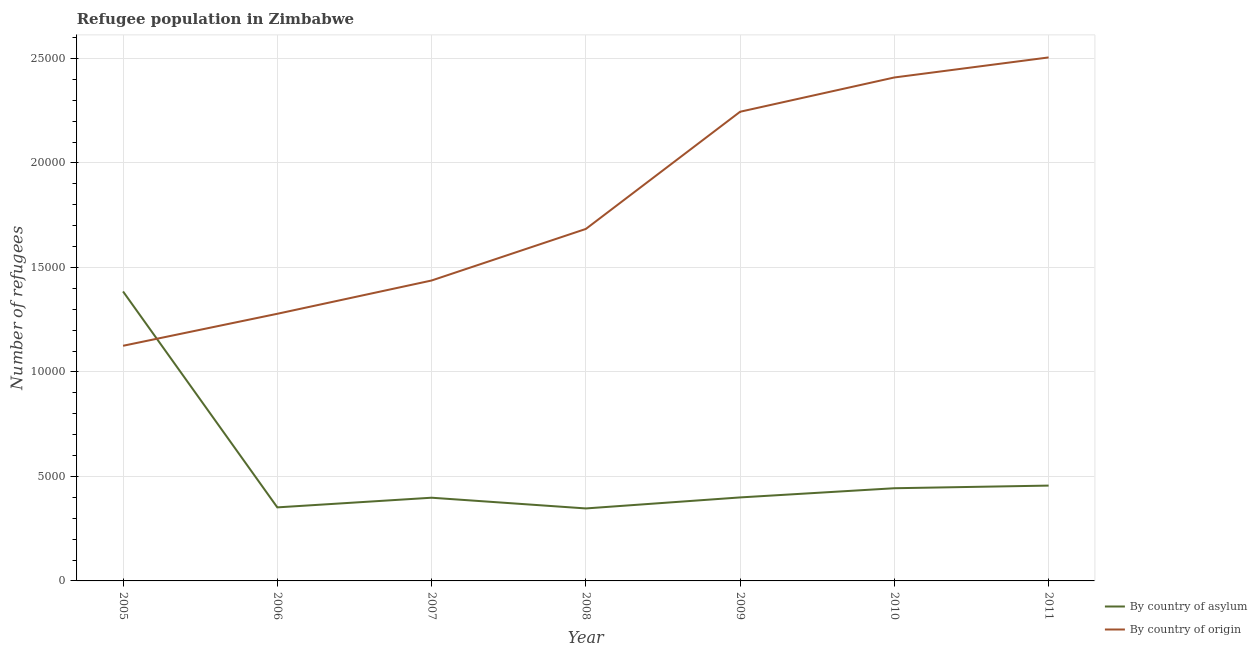Does the line corresponding to number of refugees by country of asylum intersect with the line corresponding to number of refugees by country of origin?
Provide a succinct answer. Yes. Is the number of lines equal to the number of legend labels?
Offer a very short reply. Yes. What is the number of refugees by country of origin in 2011?
Provide a succinct answer. 2.50e+04. Across all years, what is the maximum number of refugees by country of origin?
Offer a terse response. 2.50e+04. Across all years, what is the minimum number of refugees by country of asylum?
Ensure brevity in your answer.  3468. In which year was the number of refugees by country of origin maximum?
Provide a succinct answer. 2011. In which year was the number of refugees by country of origin minimum?
Your response must be concise. 2005. What is the total number of refugees by country of asylum in the graph?
Make the answer very short. 3.78e+04. What is the difference between the number of refugees by country of origin in 2007 and that in 2011?
Keep it short and to the point. -1.07e+04. What is the difference between the number of refugees by country of origin in 2009 and the number of refugees by country of asylum in 2006?
Keep it short and to the point. 1.89e+04. What is the average number of refugees by country of origin per year?
Make the answer very short. 1.81e+04. In the year 2006, what is the difference between the number of refugees by country of origin and number of refugees by country of asylum?
Make the answer very short. 9263. In how many years, is the number of refugees by country of origin greater than 10000?
Offer a very short reply. 7. What is the ratio of the number of refugees by country of origin in 2006 to that in 2010?
Make the answer very short. 0.53. What is the difference between the highest and the second highest number of refugees by country of asylum?
Your response must be concise. 9289. What is the difference between the highest and the lowest number of refugees by country of asylum?
Your answer should be very brief. 1.04e+04. Does the number of refugees by country of origin monotonically increase over the years?
Provide a succinct answer. Yes. Is the number of refugees by country of asylum strictly less than the number of refugees by country of origin over the years?
Your response must be concise. No. How many lines are there?
Ensure brevity in your answer.  2. What is the difference between two consecutive major ticks on the Y-axis?
Your response must be concise. 5000. Are the values on the major ticks of Y-axis written in scientific E-notation?
Provide a succinct answer. No. What is the title of the graph?
Provide a short and direct response. Refugee population in Zimbabwe. What is the label or title of the Y-axis?
Offer a terse response. Number of refugees. What is the Number of refugees in By country of asylum in 2005?
Provide a short and direct response. 1.38e+04. What is the Number of refugees in By country of origin in 2005?
Offer a terse response. 1.13e+04. What is the Number of refugees of By country of asylum in 2006?
Provide a succinct answer. 3519. What is the Number of refugees in By country of origin in 2006?
Your answer should be very brief. 1.28e+04. What is the Number of refugees in By country of asylum in 2007?
Your answer should be compact. 3981. What is the Number of refugees in By country of origin in 2007?
Your answer should be compact. 1.44e+04. What is the Number of refugees of By country of asylum in 2008?
Provide a succinct answer. 3468. What is the Number of refugees of By country of origin in 2008?
Your answer should be very brief. 1.68e+04. What is the Number of refugees of By country of asylum in 2009?
Offer a terse response. 3995. What is the Number of refugees in By country of origin in 2009?
Make the answer very short. 2.24e+04. What is the Number of refugees of By country of asylum in 2010?
Your answer should be very brief. 4435. What is the Number of refugees in By country of origin in 2010?
Offer a terse response. 2.41e+04. What is the Number of refugees in By country of asylum in 2011?
Provide a short and direct response. 4561. What is the Number of refugees in By country of origin in 2011?
Keep it short and to the point. 2.50e+04. Across all years, what is the maximum Number of refugees in By country of asylum?
Offer a very short reply. 1.38e+04. Across all years, what is the maximum Number of refugees of By country of origin?
Provide a short and direct response. 2.50e+04. Across all years, what is the minimum Number of refugees of By country of asylum?
Offer a terse response. 3468. Across all years, what is the minimum Number of refugees of By country of origin?
Keep it short and to the point. 1.13e+04. What is the total Number of refugees of By country of asylum in the graph?
Ensure brevity in your answer.  3.78e+04. What is the total Number of refugees in By country of origin in the graph?
Keep it short and to the point. 1.27e+05. What is the difference between the Number of refugees of By country of asylum in 2005 and that in 2006?
Keep it short and to the point. 1.03e+04. What is the difference between the Number of refugees of By country of origin in 2005 and that in 2006?
Your answer should be very brief. -1531. What is the difference between the Number of refugees in By country of asylum in 2005 and that in 2007?
Keep it short and to the point. 9869. What is the difference between the Number of refugees of By country of origin in 2005 and that in 2007?
Ensure brevity in your answer.  -3123. What is the difference between the Number of refugees of By country of asylum in 2005 and that in 2008?
Offer a very short reply. 1.04e+04. What is the difference between the Number of refugees of By country of origin in 2005 and that in 2008?
Offer a very short reply. -5590. What is the difference between the Number of refugees of By country of asylum in 2005 and that in 2009?
Ensure brevity in your answer.  9855. What is the difference between the Number of refugees in By country of origin in 2005 and that in 2009?
Keep it short and to the point. -1.12e+04. What is the difference between the Number of refugees of By country of asylum in 2005 and that in 2010?
Your response must be concise. 9415. What is the difference between the Number of refugees of By country of origin in 2005 and that in 2010?
Your response must be concise. -1.28e+04. What is the difference between the Number of refugees in By country of asylum in 2005 and that in 2011?
Offer a terse response. 9289. What is the difference between the Number of refugees of By country of origin in 2005 and that in 2011?
Offer a terse response. -1.38e+04. What is the difference between the Number of refugees in By country of asylum in 2006 and that in 2007?
Offer a terse response. -462. What is the difference between the Number of refugees in By country of origin in 2006 and that in 2007?
Your answer should be very brief. -1592. What is the difference between the Number of refugees in By country of origin in 2006 and that in 2008?
Make the answer very short. -4059. What is the difference between the Number of refugees of By country of asylum in 2006 and that in 2009?
Your response must be concise. -476. What is the difference between the Number of refugees in By country of origin in 2006 and that in 2009?
Provide a succinct answer. -9667. What is the difference between the Number of refugees in By country of asylum in 2006 and that in 2010?
Your answer should be compact. -916. What is the difference between the Number of refugees in By country of origin in 2006 and that in 2010?
Your answer should be compact. -1.13e+04. What is the difference between the Number of refugees of By country of asylum in 2006 and that in 2011?
Keep it short and to the point. -1042. What is the difference between the Number of refugees in By country of origin in 2006 and that in 2011?
Offer a very short reply. -1.23e+04. What is the difference between the Number of refugees of By country of asylum in 2007 and that in 2008?
Provide a succinct answer. 513. What is the difference between the Number of refugees in By country of origin in 2007 and that in 2008?
Your response must be concise. -2467. What is the difference between the Number of refugees of By country of origin in 2007 and that in 2009?
Your response must be concise. -8075. What is the difference between the Number of refugees of By country of asylum in 2007 and that in 2010?
Provide a succinct answer. -454. What is the difference between the Number of refugees in By country of origin in 2007 and that in 2010?
Provide a succinct answer. -9715. What is the difference between the Number of refugees of By country of asylum in 2007 and that in 2011?
Ensure brevity in your answer.  -580. What is the difference between the Number of refugees of By country of origin in 2007 and that in 2011?
Your answer should be compact. -1.07e+04. What is the difference between the Number of refugees in By country of asylum in 2008 and that in 2009?
Ensure brevity in your answer.  -527. What is the difference between the Number of refugees in By country of origin in 2008 and that in 2009?
Provide a succinct answer. -5608. What is the difference between the Number of refugees of By country of asylum in 2008 and that in 2010?
Give a very brief answer. -967. What is the difference between the Number of refugees in By country of origin in 2008 and that in 2010?
Provide a succinct answer. -7248. What is the difference between the Number of refugees of By country of asylum in 2008 and that in 2011?
Your answer should be compact. -1093. What is the difference between the Number of refugees in By country of origin in 2008 and that in 2011?
Ensure brevity in your answer.  -8207. What is the difference between the Number of refugees of By country of asylum in 2009 and that in 2010?
Provide a succinct answer. -440. What is the difference between the Number of refugees in By country of origin in 2009 and that in 2010?
Make the answer very short. -1640. What is the difference between the Number of refugees in By country of asylum in 2009 and that in 2011?
Your answer should be very brief. -566. What is the difference between the Number of refugees of By country of origin in 2009 and that in 2011?
Give a very brief answer. -2599. What is the difference between the Number of refugees of By country of asylum in 2010 and that in 2011?
Your answer should be very brief. -126. What is the difference between the Number of refugees of By country of origin in 2010 and that in 2011?
Your answer should be compact. -959. What is the difference between the Number of refugees in By country of asylum in 2005 and the Number of refugees in By country of origin in 2006?
Give a very brief answer. 1068. What is the difference between the Number of refugees in By country of asylum in 2005 and the Number of refugees in By country of origin in 2007?
Keep it short and to the point. -524. What is the difference between the Number of refugees of By country of asylum in 2005 and the Number of refugees of By country of origin in 2008?
Offer a terse response. -2991. What is the difference between the Number of refugees in By country of asylum in 2005 and the Number of refugees in By country of origin in 2009?
Keep it short and to the point. -8599. What is the difference between the Number of refugees in By country of asylum in 2005 and the Number of refugees in By country of origin in 2010?
Your answer should be compact. -1.02e+04. What is the difference between the Number of refugees in By country of asylum in 2005 and the Number of refugees in By country of origin in 2011?
Make the answer very short. -1.12e+04. What is the difference between the Number of refugees of By country of asylum in 2006 and the Number of refugees of By country of origin in 2007?
Make the answer very short. -1.09e+04. What is the difference between the Number of refugees of By country of asylum in 2006 and the Number of refugees of By country of origin in 2008?
Provide a short and direct response. -1.33e+04. What is the difference between the Number of refugees in By country of asylum in 2006 and the Number of refugees in By country of origin in 2009?
Provide a succinct answer. -1.89e+04. What is the difference between the Number of refugees of By country of asylum in 2006 and the Number of refugees of By country of origin in 2010?
Offer a very short reply. -2.06e+04. What is the difference between the Number of refugees in By country of asylum in 2006 and the Number of refugees in By country of origin in 2011?
Your response must be concise. -2.15e+04. What is the difference between the Number of refugees in By country of asylum in 2007 and the Number of refugees in By country of origin in 2008?
Your answer should be compact. -1.29e+04. What is the difference between the Number of refugees in By country of asylum in 2007 and the Number of refugees in By country of origin in 2009?
Offer a terse response. -1.85e+04. What is the difference between the Number of refugees of By country of asylum in 2007 and the Number of refugees of By country of origin in 2010?
Offer a terse response. -2.01e+04. What is the difference between the Number of refugees of By country of asylum in 2007 and the Number of refugees of By country of origin in 2011?
Your answer should be compact. -2.11e+04. What is the difference between the Number of refugees of By country of asylum in 2008 and the Number of refugees of By country of origin in 2009?
Your answer should be very brief. -1.90e+04. What is the difference between the Number of refugees in By country of asylum in 2008 and the Number of refugees in By country of origin in 2010?
Your response must be concise. -2.06e+04. What is the difference between the Number of refugees in By country of asylum in 2008 and the Number of refugees in By country of origin in 2011?
Your answer should be very brief. -2.16e+04. What is the difference between the Number of refugees in By country of asylum in 2009 and the Number of refugees in By country of origin in 2010?
Keep it short and to the point. -2.01e+04. What is the difference between the Number of refugees of By country of asylum in 2009 and the Number of refugees of By country of origin in 2011?
Your response must be concise. -2.11e+04. What is the difference between the Number of refugees in By country of asylum in 2010 and the Number of refugees in By country of origin in 2011?
Your response must be concise. -2.06e+04. What is the average Number of refugees in By country of asylum per year?
Your answer should be compact. 5401.29. What is the average Number of refugees in By country of origin per year?
Ensure brevity in your answer.  1.81e+04. In the year 2005, what is the difference between the Number of refugees of By country of asylum and Number of refugees of By country of origin?
Offer a terse response. 2599. In the year 2006, what is the difference between the Number of refugees in By country of asylum and Number of refugees in By country of origin?
Your answer should be compact. -9263. In the year 2007, what is the difference between the Number of refugees in By country of asylum and Number of refugees in By country of origin?
Your answer should be very brief. -1.04e+04. In the year 2008, what is the difference between the Number of refugees of By country of asylum and Number of refugees of By country of origin?
Ensure brevity in your answer.  -1.34e+04. In the year 2009, what is the difference between the Number of refugees of By country of asylum and Number of refugees of By country of origin?
Ensure brevity in your answer.  -1.85e+04. In the year 2010, what is the difference between the Number of refugees in By country of asylum and Number of refugees in By country of origin?
Offer a terse response. -1.97e+04. In the year 2011, what is the difference between the Number of refugees in By country of asylum and Number of refugees in By country of origin?
Your answer should be very brief. -2.05e+04. What is the ratio of the Number of refugees in By country of asylum in 2005 to that in 2006?
Your answer should be very brief. 3.94. What is the ratio of the Number of refugees of By country of origin in 2005 to that in 2006?
Give a very brief answer. 0.88. What is the ratio of the Number of refugees of By country of asylum in 2005 to that in 2007?
Offer a very short reply. 3.48. What is the ratio of the Number of refugees of By country of origin in 2005 to that in 2007?
Provide a succinct answer. 0.78. What is the ratio of the Number of refugees in By country of asylum in 2005 to that in 2008?
Your answer should be very brief. 3.99. What is the ratio of the Number of refugees in By country of origin in 2005 to that in 2008?
Offer a terse response. 0.67. What is the ratio of the Number of refugees of By country of asylum in 2005 to that in 2009?
Offer a terse response. 3.47. What is the ratio of the Number of refugees in By country of origin in 2005 to that in 2009?
Offer a terse response. 0.5. What is the ratio of the Number of refugees in By country of asylum in 2005 to that in 2010?
Offer a very short reply. 3.12. What is the ratio of the Number of refugees in By country of origin in 2005 to that in 2010?
Your answer should be very brief. 0.47. What is the ratio of the Number of refugees in By country of asylum in 2005 to that in 2011?
Ensure brevity in your answer.  3.04. What is the ratio of the Number of refugees in By country of origin in 2005 to that in 2011?
Provide a succinct answer. 0.45. What is the ratio of the Number of refugees of By country of asylum in 2006 to that in 2007?
Ensure brevity in your answer.  0.88. What is the ratio of the Number of refugees in By country of origin in 2006 to that in 2007?
Offer a terse response. 0.89. What is the ratio of the Number of refugees of By country of asylum in 2006 to that in 2008?
Give a very brief answer. 1.01. What is the ratio of the Number of refugees of By country of origin in 2006 to that in 2008?
Provide a short and direct response. 0.76. What is the ratio of the Number of refugees of By country of asylum in 2006 to that in 2009?
Your response must be concise. 0.88. What is the ratio of the Number of refugees in By country of origin in 2006 to that in 2009?
Your answer should be compact. 0.57. What is the ratio of the Number of refugees in By country of asylum in 2006 to that in 2010?
Offer a terse response. 0.79. What is the ratio of the Number of refugees in By country of origin in 2006 to that in 2010?
Your answer should be very brief. 0.53. What is the ratio of the Number of refugees of By country of asylum in 2006 to that in 2011?
Your response must be concise. 0.77. What is the ratio of the Number of refugees of By country of origin in 2006 to that in 2011?
Give a very brief answer. 0.51. What is the ratio of the Number of refugees in By country of asylum in 2007 to that in 2008?
Provide a short and direct response. 1.15. What is the ratio of the Number of refugees in By country of origin in 2007 to that in 2008?
Provide a succinct answer. 0.85. What is the ratio of the Number of refugees in By country of asylum in 2007 to that in 2009?
Ensure brevity in your answer.  1. What is the ratio of the Number of refugees of By country of origin in 2007 to that in 2009?
Your answer should be compact. 0.64. What is the ratio of the Number of refugees in By country of asylum in 2007 to that in 2010?
Offer a very short reply. 0.9. What is the ratio of the Number of refugees of By country of origin in 2007 to that in 2010?
Ensure brevity in your answer.  0.6. What is the ratio of the Number of refugees in By country of asylum in 2007 to that in 2011?
Offer a very short reply. 0.87. What is the ratio of the Number of refugees of By country of origin in 2007 to that in 2011?
Provide a short and direct response. 0.57. What is the ratio of the Number of refugees of By country of asylum in 2008 to that in 2009?
Your response must be concise. 0.87. What is the ratio of the Number of refugees in By country of origin in 2008 to that in 2009?
Ensure brevity in your answer.  0.75. What is the ratio of the Number of refugees in By country of asylum in 2008 to that in 2010?
Give a very brief answer. 0.78. What is the ratio of the Number of refugees of By country of origin in 2008 to that in 2010?
Ensure brevity in your answer.  0.7. What is the ratio of the Number of refugees of By country of asylum in 2008 to that in 2011?
Ensure brevity in your answer.  0.76. What is the ratio of the Number of refugees of By country of origin in 2008 to that in 2011?
Ensure brevity in your answer.  0.67. What is the ratio of the Number of refugees in By country of asylum in 2009 to that in 2010?
Your response must be concise. 0.9. What is the ratio of the Number of refugees in By country of origin in 2009 to that in 2010?
Ensure brevity in your answer.  0.93. What is the ratio of the Number of refugees of By country of asylum in 2009 to that in 2011?
Give a very brief answer. 0.88. What is the ratio of the Number of refugees of By country of origin in 2009 to that in 2011?
Ensure brevity in your answer.  0.9. What is the ratio of the Number of refugees of By country of asylum in 2010 to that in 2011?
Ensure brevity in your answer.  0.97. What is the ratio of the Number of refugees of By country of origin in 2010 to that in 2011?
Keep it short and to the point. 0.96. What is the difference between the highest and the second highest Number of refugees of By country of asylum?
Provide a succinct answer. 9289. What is the difference between the highest and the second highest Number of refugees in By country of origin?
Offer a terse response. 959. What is the difference between the highest and the lowest Number of refugees in By country of asylum?
Your answer should be compact. 1.04e+04. What is the difference between the highest and the lowest Number of refugees of By country of origin?
Your answer should be very brief. 1.38e+04. 